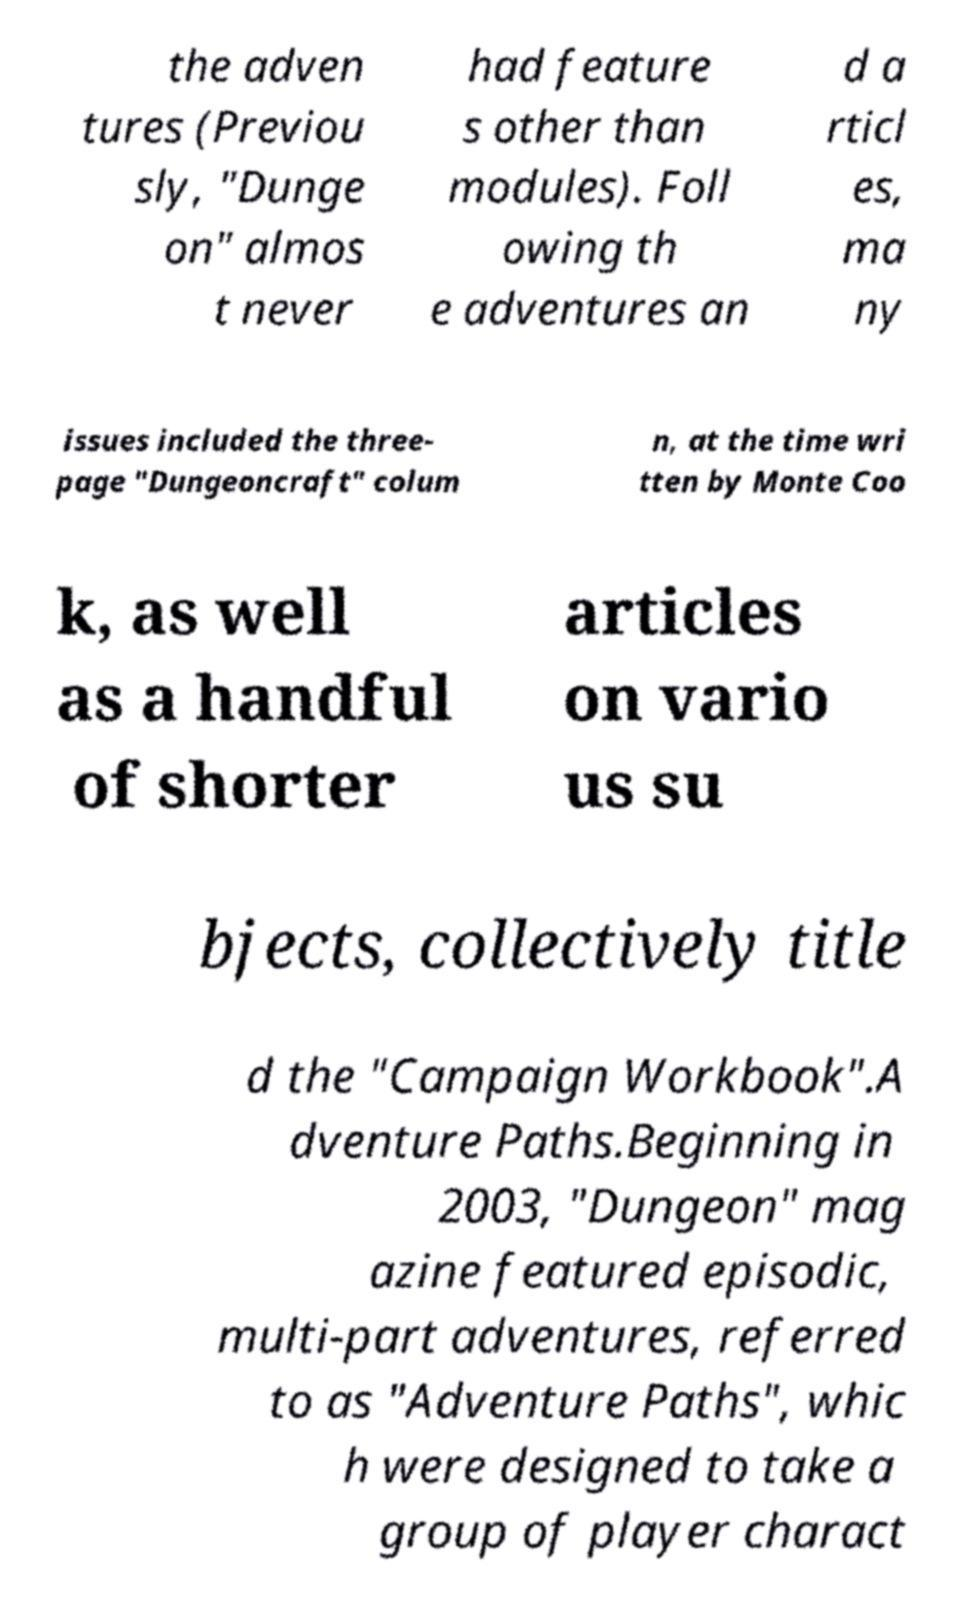Can you read and provide the text displayed in the image?This photo seems to have some interesting text. Can you extract and type it out for me? the adven tures (Previou sly, "Dunge on" almos t never had feature s other than modules). Foll owing th e adventures an d a rticl es, ma ny issues included the three- page "Dungeoncraft" colum n, at the time wri tten by Monte Coo k, as well as a handful of shorter articles on vario us su bjects, collectively title d the "Campaign Workbook".A dventure Paths.Beginning in 2003, "Dungeon" mag azine featured episodic, multi-part adventures, referred to as "Adventure Paths", whic h were designed to take a group of player charact 